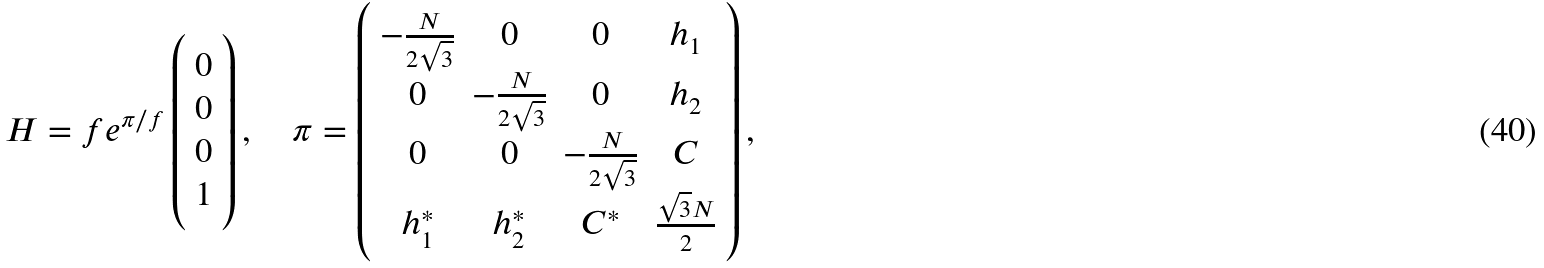<formula> <loc_0><loc_0><loc_500><loc_500>H = f e ^ { \pi / f } \left ( \begin{array} { c } 0 \\ 0 \\ 0 \\ 1 \end{array} \right ) , \quad \pi = \left ( \begin{array} { c c c c } - \frac { N } { 2 \sqrt { 3 } } & 0 & 0 & h _ { 1 } \\ 0 & - \frac { N } { 2 \sqrt { 3 } } & 0 & h _ { 2 } \\ 0 & 0 & - \frac { N } { 2 \sqrt { 3 } } & C \\ h ^ { \ast } _ { 1 } & h ^ { \ast } _ { 2 } & C ^ { \ast } & \frac { \sqrt { 3 } N } { 2 } \end{array} \right ) ,</formula> 